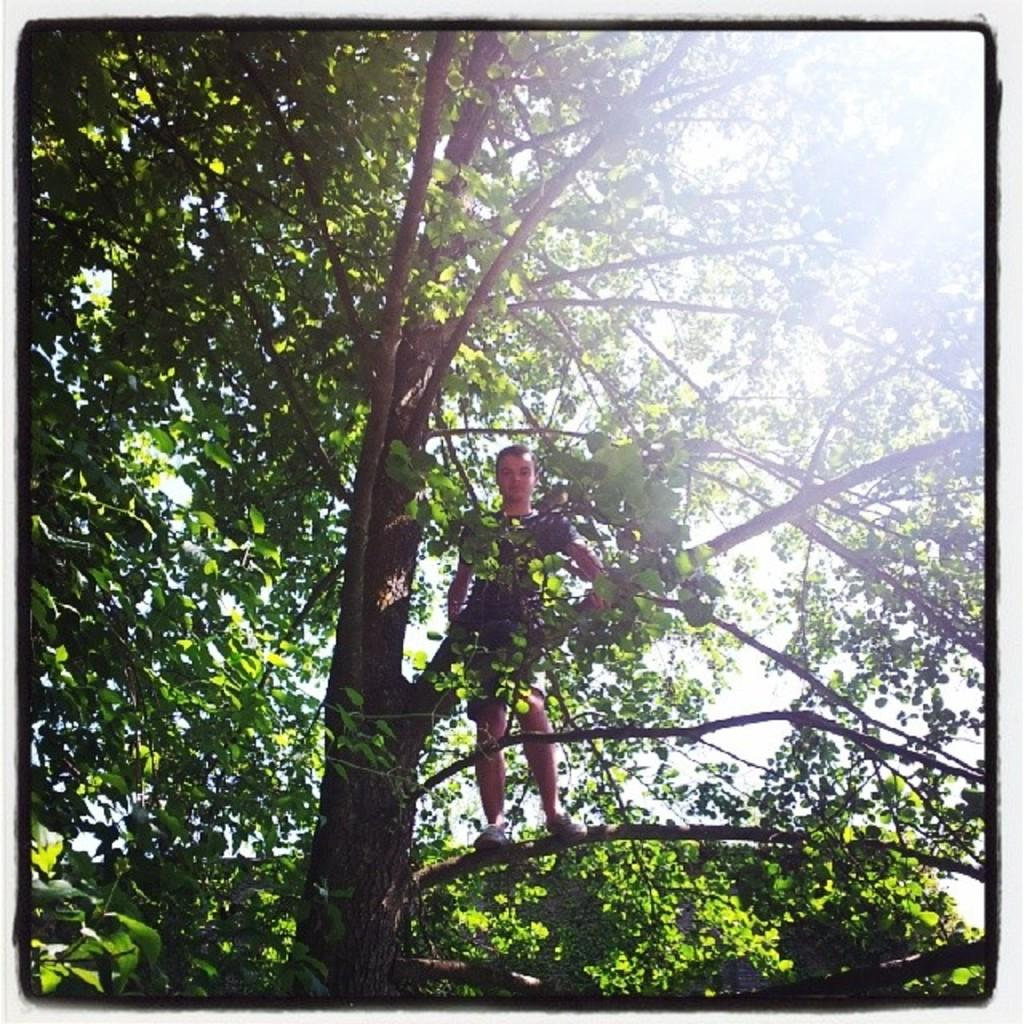What is the person in the image doing? The person is standing on a tree in the image. What can be seen behind the tree in the image? The sky is visible behind the tree in the image. What type of scarf is the person wearing while standing on the tree in the image? There is no scarf visible in the image; the person is not wearing one. 